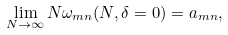Convert formula to latex. <formula><loc_0><loc_0><loc_500><loc_500>\lim _ { N \to \infty } N \omega _ { m n } ( N , \delta = 0 ) = a _ { m n } ,</formula> 